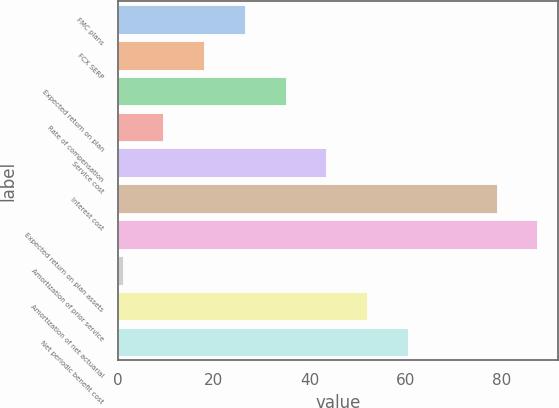Convert chart to OTSL. <chart><loc_0><loc_0><loc_500><loc_500><bar_chart><fcel>FMC plans<fcel>FCX SERP<fcel>Expected return on plan<fcel>Rate of compensation<fcel>Service cost<fcel>Interest cost<fcel>Expected return on plan assets<fcel>Amortization of prior service<fcel>Amortization of net actuarial<fcel>Net periodic benefit cost<nl><fcel>26.5<fcel>18<fcel>35<fcel>9.5<fcel>43.5<fcel>79<fcel>87.5<fcel>1<fcel>52<fcel>60.5<nl></chart> 